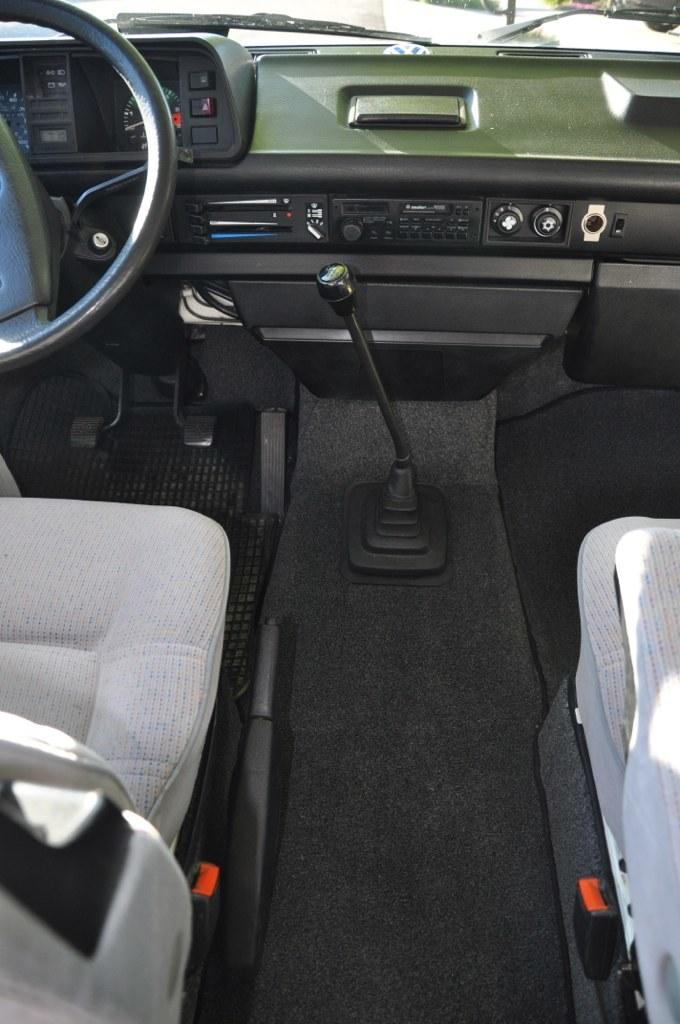What is the setting of the image? The image is taken inside a vehicle. What can be found inside the vehicle? There are seats, a steering wheel, switches, and a wiper in the vehicle. What type of light is being used to illuminate the group of people in the image? There is no group of people present in the image, and no light source is visible. 